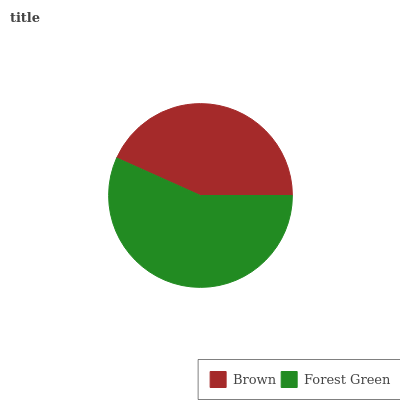Is Brown the minimum?
Answer yes or no. Yes. Is Forest Green the maximum?
Answer yes or no. Yes. Is Forest Green the minimum?
Answer yes or no. No. Is Forest Green greater than Brown?
Answer yes or no. Yes. Is Brown less than Forest Green?
Answer yes or no. Yes. Is Brown greater than Forest Green?
Answer yes or no. No. Is Forest Green less than Brown?
Answer yes or no. No. Is Forest Green the high median?
Answer yes or no. Yes. Is Brown the low median?
Answer yes or no. Yes. Is Brown the high median?
Answer yes or no. No. Is Forest Green the low median?
Answer yes or no. No. 